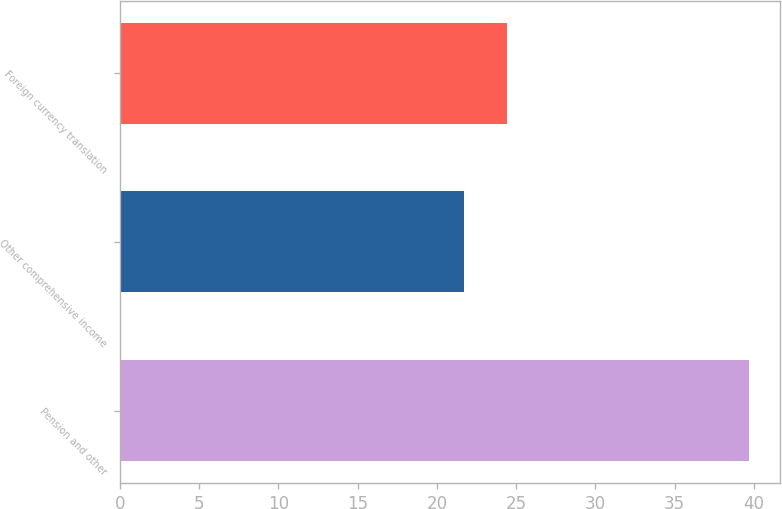Convert chart to OTSL. <chart><loc_0><loc_0><loc_500><loc_500><bar_chart><fcel>Pension and other<fcel>Other comprehensive income<fcel>Foreign currency translation<nl><fcel>39.7<fcel>21.7<fcel>24.4<nl></chart> 